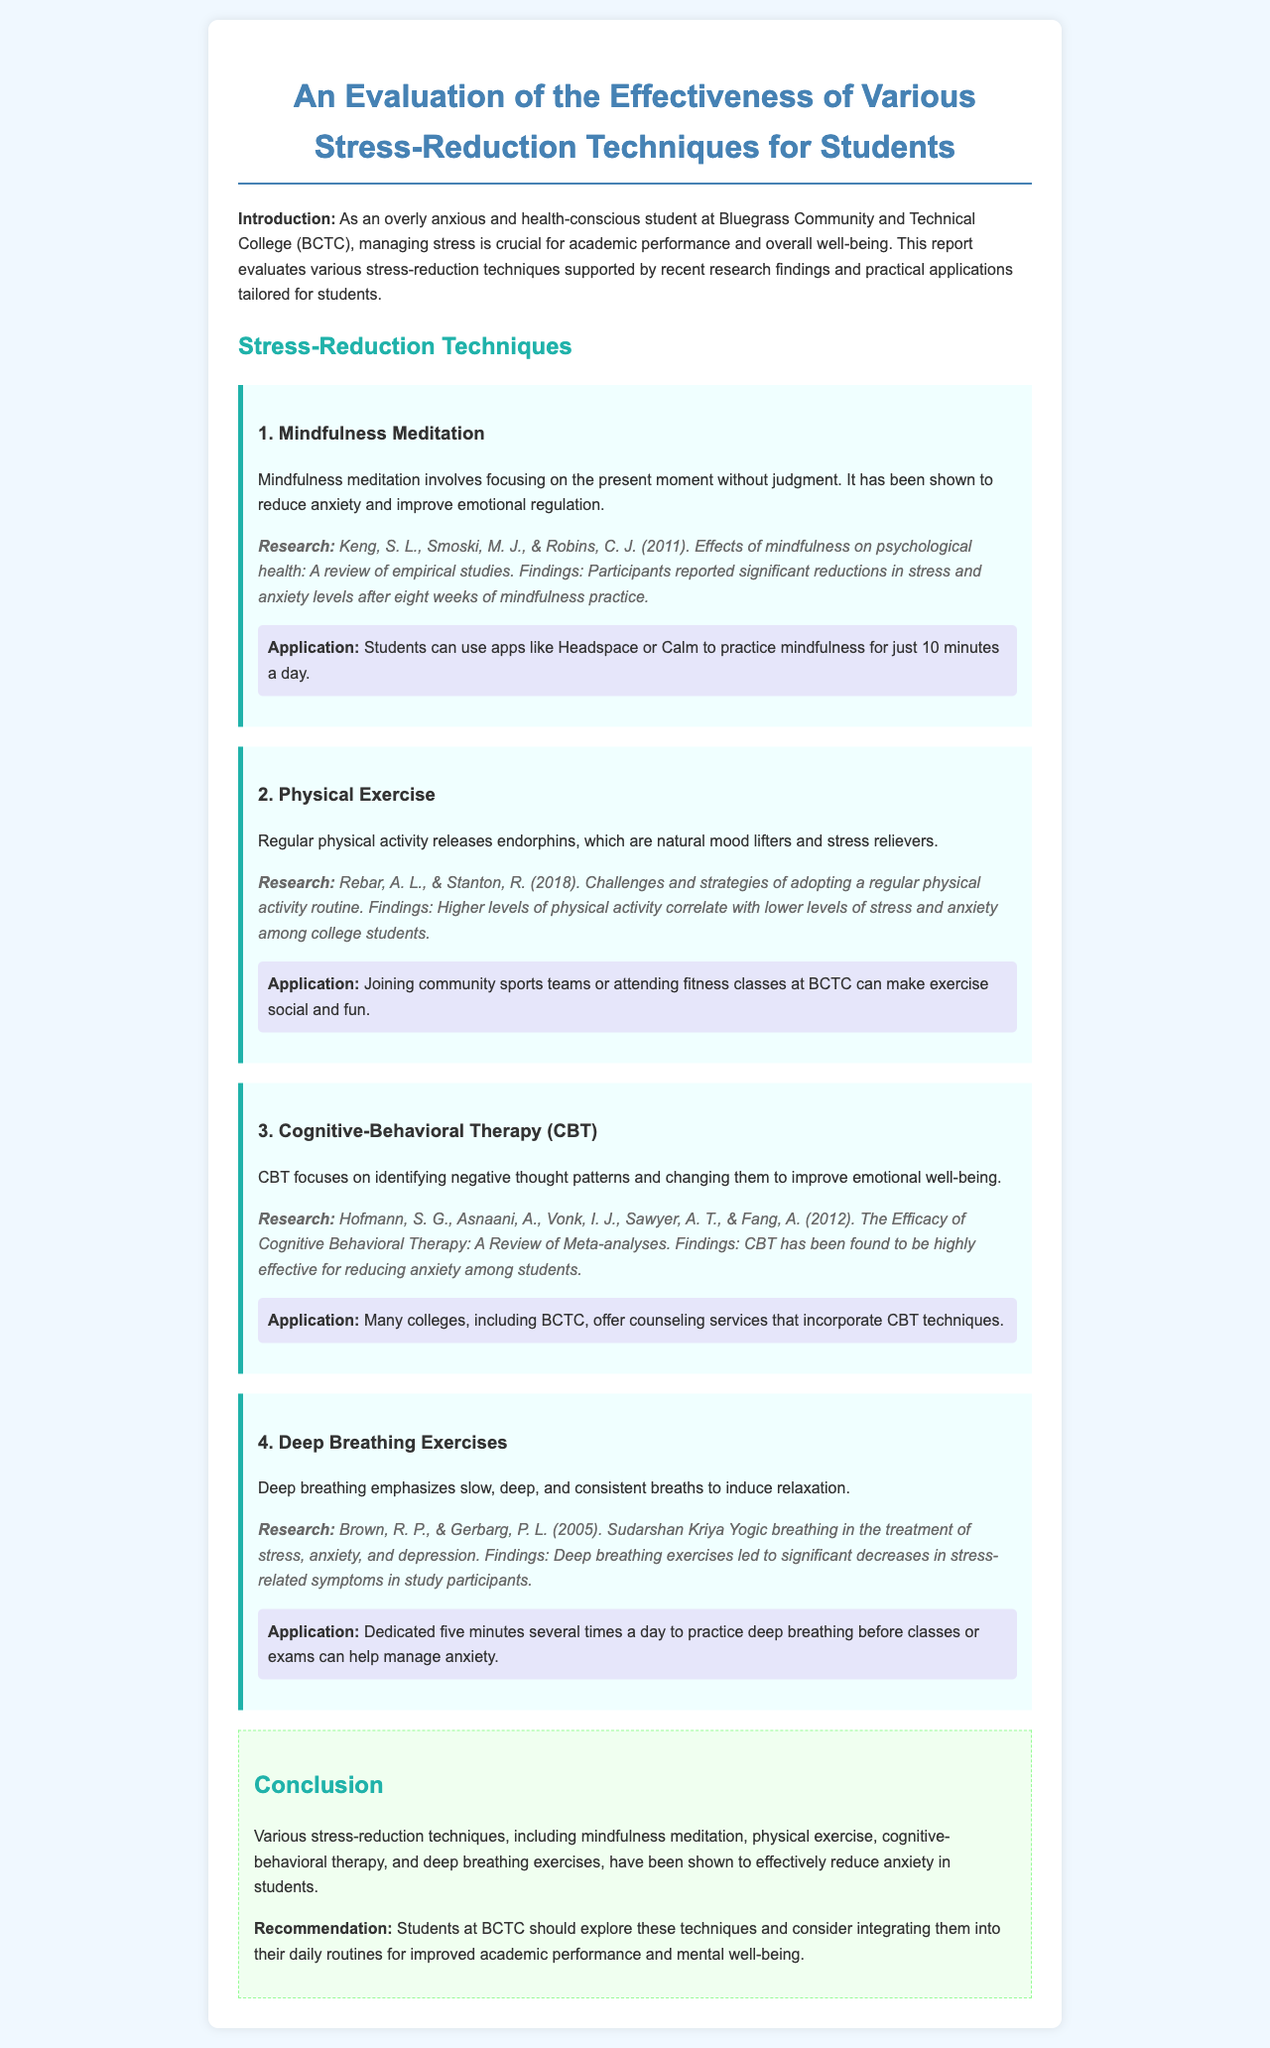what is the first stress-reduction technique mentioned? The first stress-reduction technique listed in the document is "Mindfulness Meditation."
Answer: Mindfulness Meditation who are the authors of the research on mindfulness? The authors of the research on mindfulness are Keng, S. L., Smoski, M. J., & Robins, C. J.
Answer: Keng, S. L., Smoski, M. J., & Robins, C. J how long did participants practice mindfulness to see results? Participants reported significant reductions in stress after practicing mindfulness for eight weeks.
Answer: eight weeks what benefits are associated with regular physical exercise according to the document? Regular physical activity is associated with releasing endorphins, which are natural mood lifters and stress relievers.
Answer: releasing endorphins what type of therapy is mentioned as effective for reducing anxiety? The type of therapy mentioned as effective for reducing anxiety is Cognitive-Behavioral Therapy (CBT).
Answer: Cognitive-Behavioral Therapy (CBT) what is the recommended application for deep breathing exercises? The recommended application is to practice deep breathing for five minutes several times a day.
Answer: five minutes several times a day what conclusion is drawn about the techniques evaluated? The conclusion drawn is that various stress-reduction techniques effectively reduce anxiety in students.
Answer: effectively reduce anxiety what is the main recommendation for students at BCTC? The main recommendation for students at BCTC is to explore and integrate stress-reduction techniques into their daily routines.
Answer: explore and integrate stress-reduction techniques 